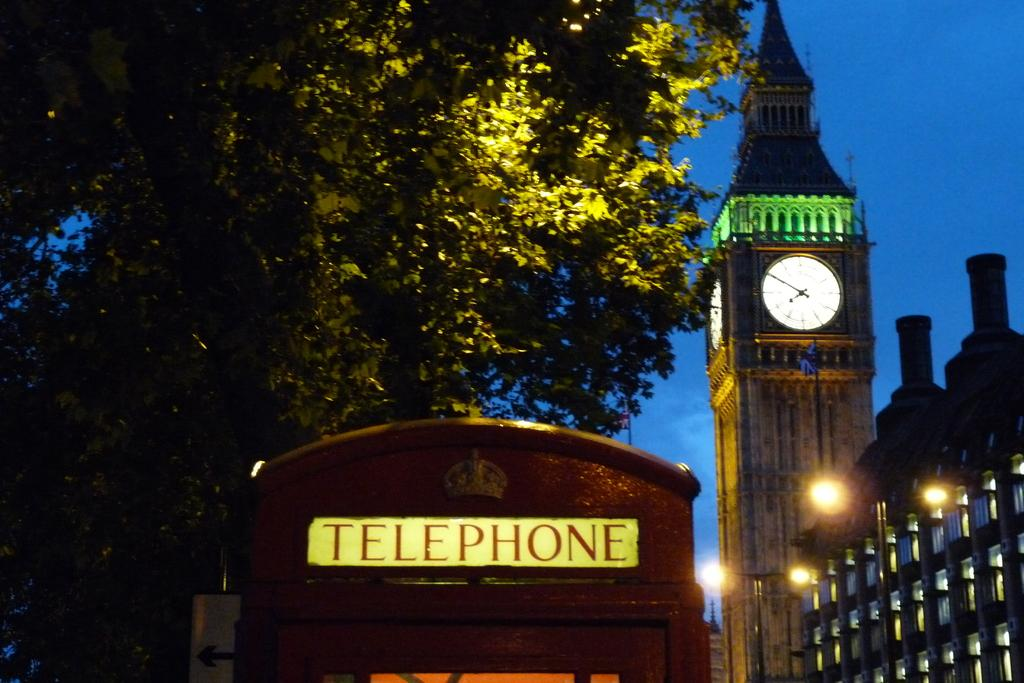<image>
Write a terse but informative summary of the picture. A telephone booth is in the foreground and in the background is Big Ben the famous London clock tower lit up in green at night. 